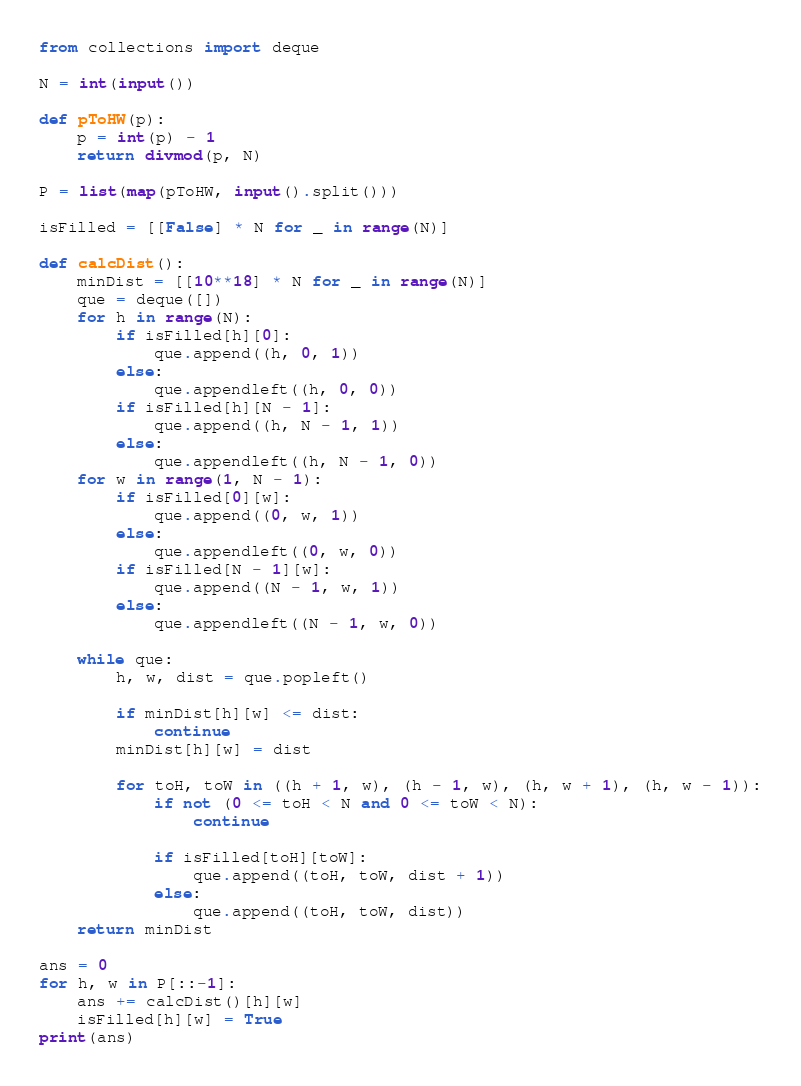<code> <loc_0><loc_0><loc_500><loc_500><_Python_>from collections import deque

N = int(input())

def pToHW(p):
    p = int(p) - 1
    return divmod(p, N)

P = list(map(pToHW, input().split()))

isFilled = [[False] * N for _ in range(N)]

def calcDist():
    minDist = [[10**18] * N for _ in range(N)]
    que = deque([])
    for h in range(N):
        if isFilled[h][0]:
            que.append((h, 0, 1))
        else:
            que.appendleft((h, 0, 0))
        if isFilled[h][N - 1]:
            que.append((h, N - 1, 1))
        else:
            que.appendleft((h, N - 1, 0))
    for w in range(1, N - 1):
        if isFilled[0][w]:
            que.append((0, w, 1))
        else:
            que.appendleft((0, w, 0))
        if isFilled[N - 1][w]:
            que.append((N - 1, w, 1))
        else:
            que.appendleft((N - 1, w, 0))

    while que:
        h, w, dist = que.popleft()

        if minDist[h][w] <= dist:
            continue
        minDist[h][w] = dist

        for toH, toW in ((h + 1, w), (h - 1, w), (h, w + 1), (h, w - 1)):
            if not (0 <= toH < N and 0 <= toW < N):
                continue

            if isFilled[toH][toW]:
                que.append((toH, toW, dist + 1))
            else:
                que.append((toH, toW, dist))
    return minDist

ans = 0
for h, w in P[::-1]:
    ans += calcDist()[h][w]
    isFilled[h][w] = True
print(ans)
</code> 